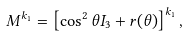Convert formula to latex. <formula><loc_0><loc_0><loc_500><loc_500>M ^ { k _ { 1 } } = \left [ \cos ^ { 2 } \theta I _ { 3 } + r ( \theta ) \right ] ^ { k _ { 1 } } ,</formula> 